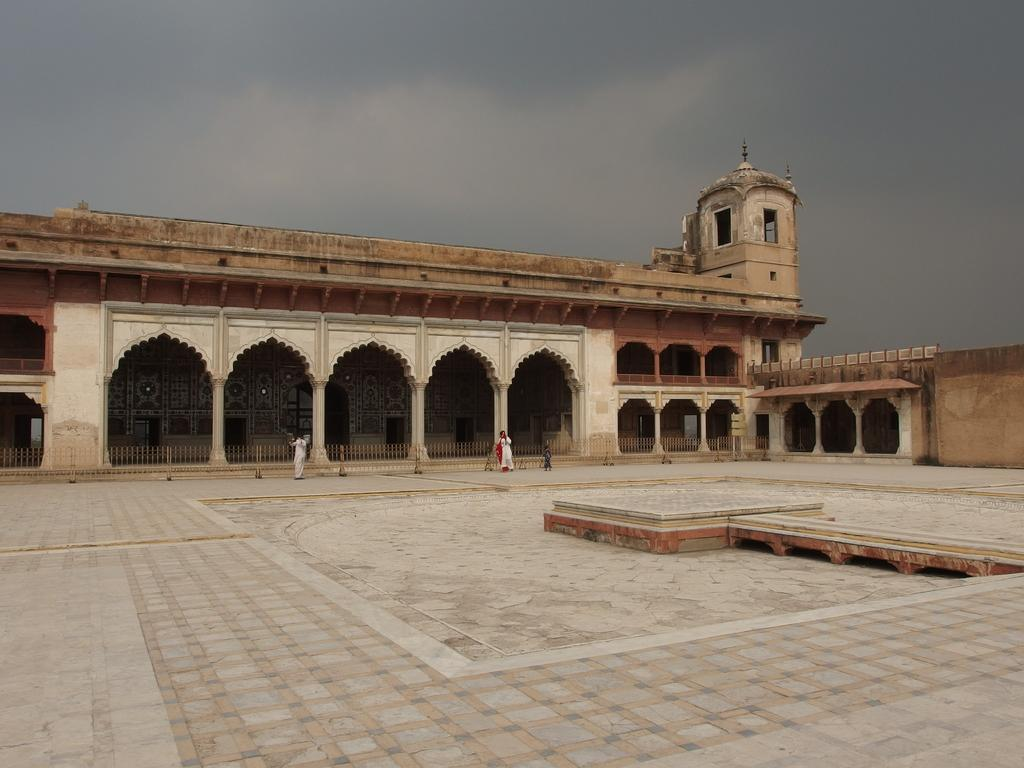What is the main subject of the image? The main subject of the image is the Lahore fort. Are there any people in the image? Yes, there are two persons standing in the image. What can be seen in the background of the image? The sky is visible in the background of the image. What type of chalk is being used by the persons in the image? There is no chalk present in the image, and therefore no such activity can be observed. 